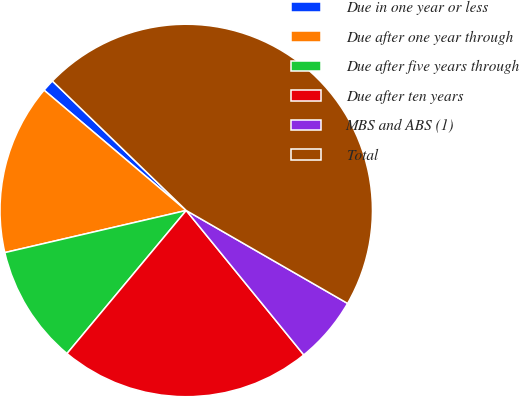Convert chart to OTSL. <chart><loc_0><loc_0><loc_500><loc_500><pie_chart><fcel>Due in one year or less<fcel>Due after one year through<fcel>Due after five years through<fcel>Due after ten years<fcel>MBS and ABS (1)<fcel>Total<nl><fcel>1.06%<fcel>14.81%<fcel>10.31%<fcel>21.93%<fcel>5.81%<fcel>46.08%<nl></chart> 